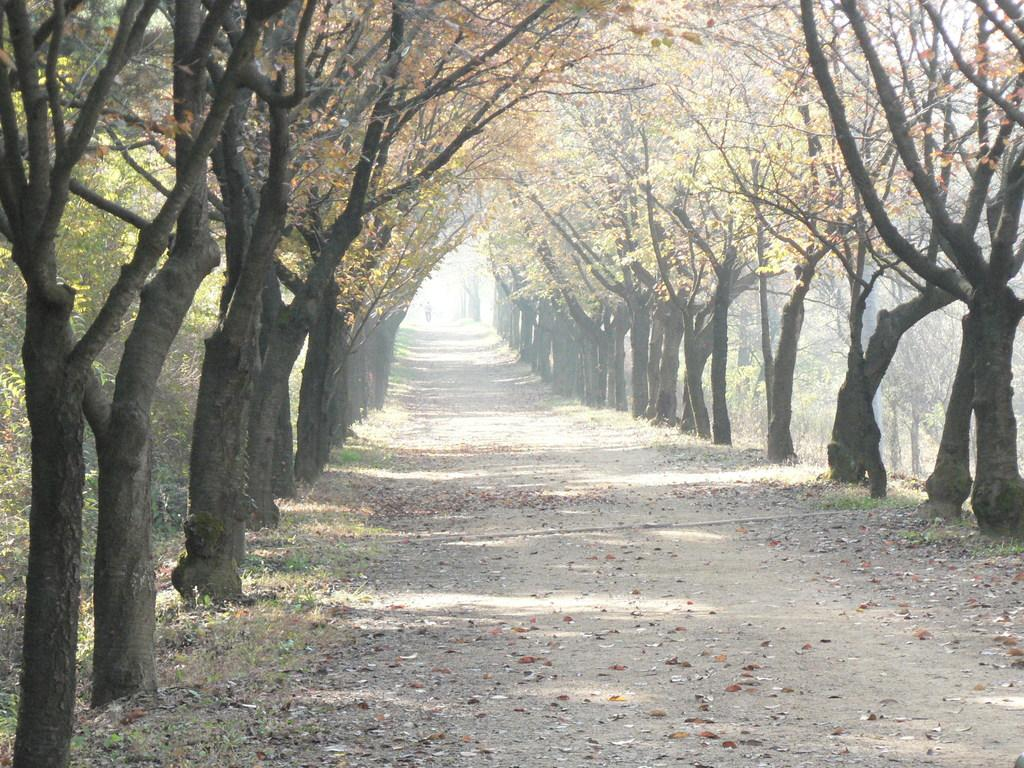What type of surface can be seen in the image? There is a road in the image. What type of vegetation is visible in the image? Grass is visible in the image. What type of organic material is present in the image? Dry leaves are present in the image. What type of natural barriers are present in the image? Trees are present on either side of the image. What type of attraction can be seen in the image? There is no attraction present in the image; it features a road, grass, dry leaves, and trees. What type of emotion is being expressed by the trees in the image? Trees do not express emotions, so it is not possible to determine any emotions from the image. 